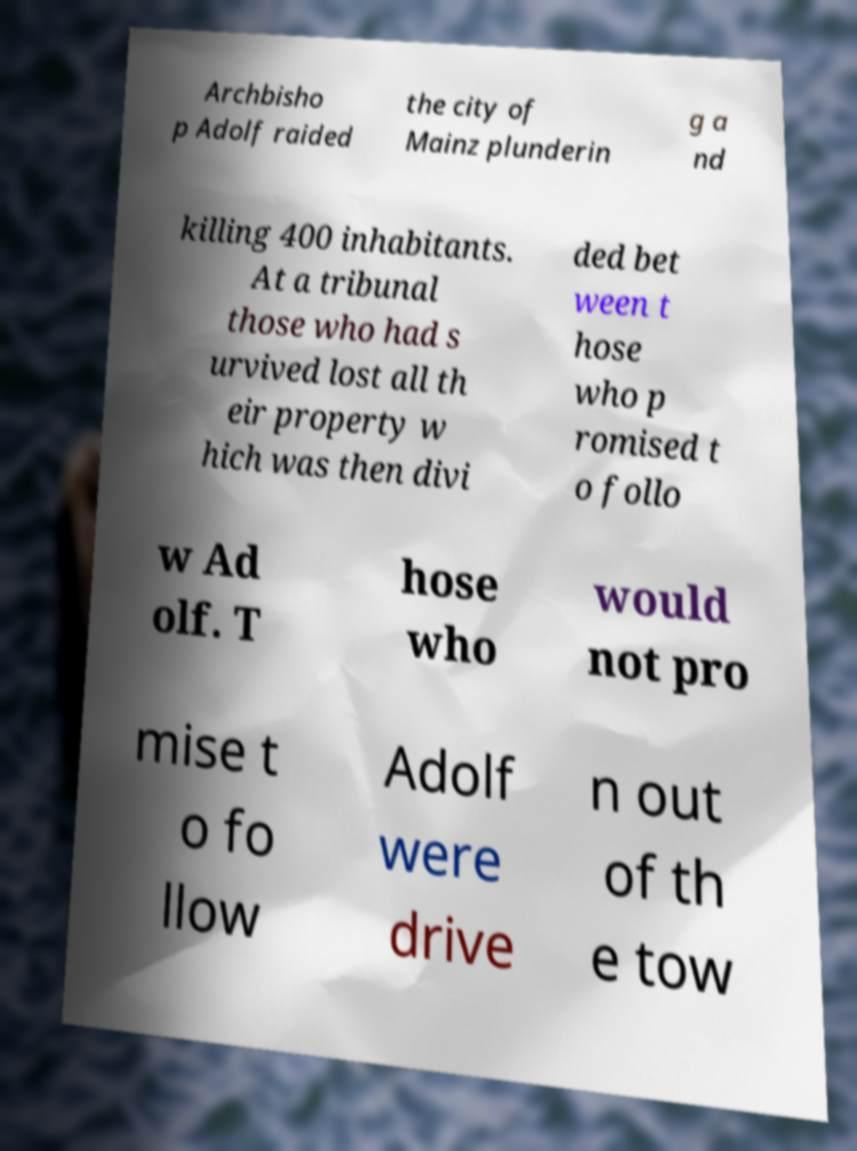Could you extract and type out the text from this image? Archbisho p Adolf raided the city of Mainz plunderin g a nd killing 400 inhabitants. At a tribunal those who had s urvived lost all th eir property w hich was then divi ded bet ween t hose who p romised t o follo w Ad olf. T hose who would not pro mise t o fo llow Adolf were drive n out of th e tow 